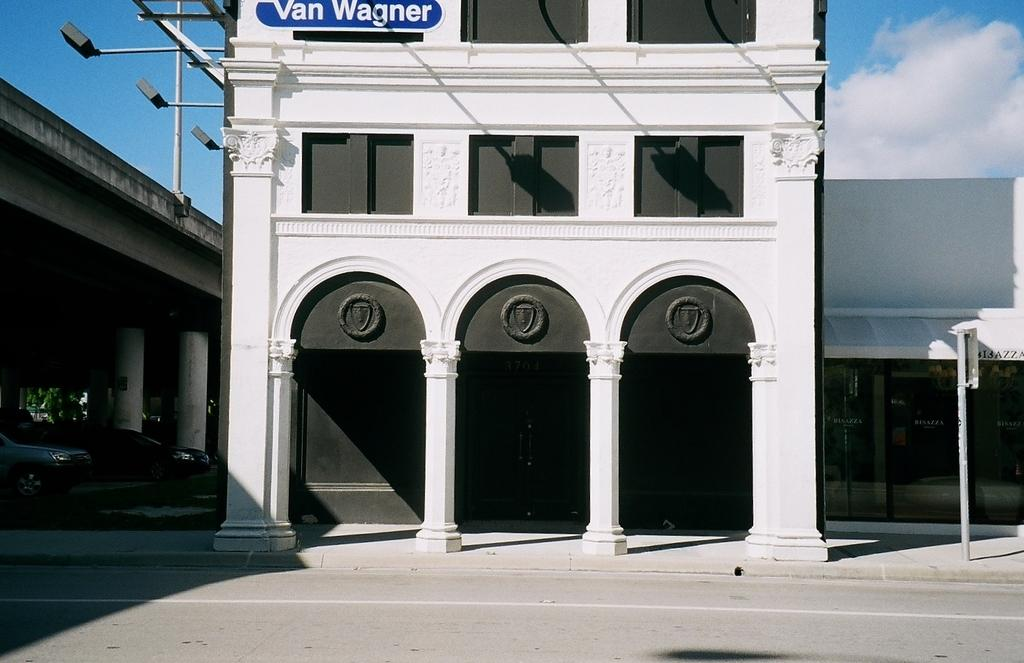What type of structure is present in the image? There is a building in the image. What architectural features can be seen on the building? There are pillars in the image. What is attached to a pole in the image? There is a board on a pole in the image. What type of vehicles are visible in the image? There are cars in the image. What can be seen in the background of the image? The sky with clouds is visible in the background of the image. What type of trousers is the building wearing in the image? Buildings do not wear trousers, so this question cannot be answered. Can you see a rifle in the image? There is no rifle present in the image. 